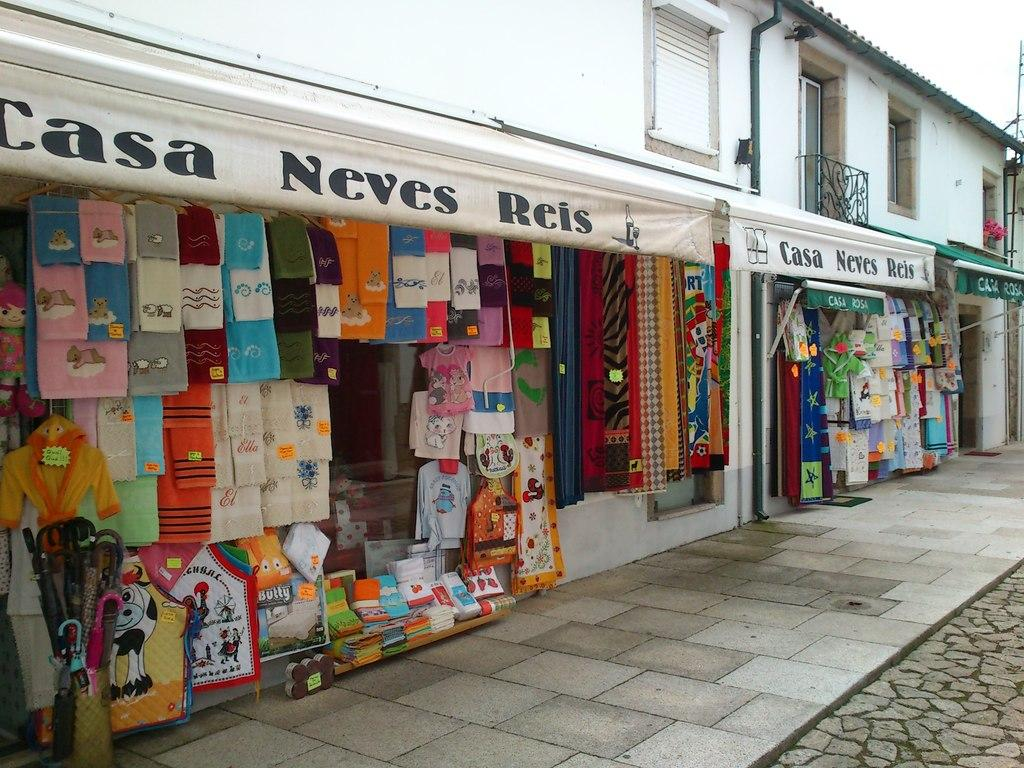<image>
Provide a brief description of the given image. The Casa Neves Reis store offers an assortment of shirt and towel products. 